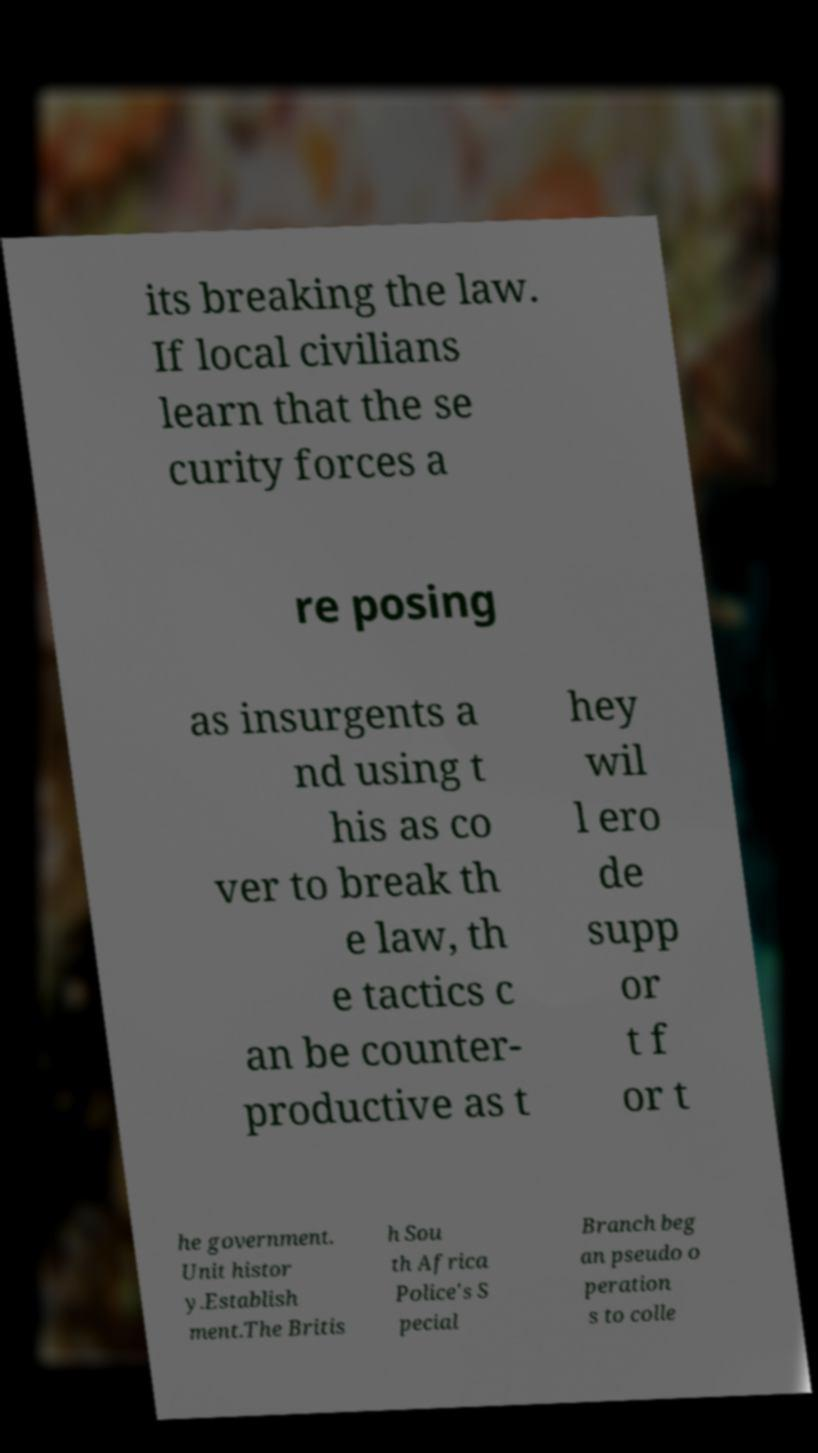Please identify and transcribe the text found in this image. its breaking the law. If local civilians learn that the se curity forces a re posing as insurgents a nd using t his as co ver to break th e law, th e tactics c an be counter- productive as t hey wil l ero de supp or t f or t he government. Unit histor y.Establish ment.The Britis h Sou th Africa Police's S pecial Branch beg an pseudo o peration s to colle 